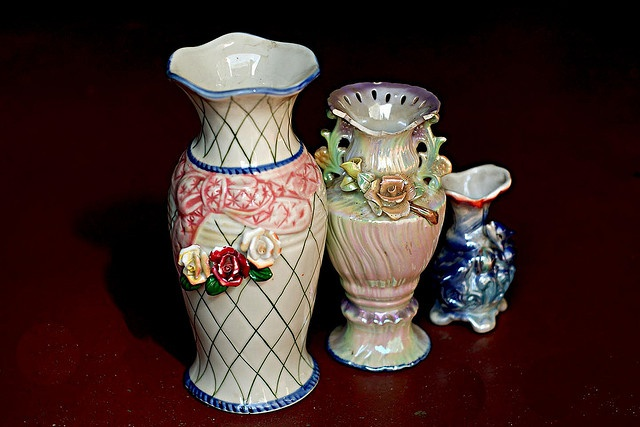Describe the objects in this image and their specific colors. I can see vase in black, darkgray, lightgray, and tan tones, vase in black, darkgray, tan, and gray tones, and vase in black, darkgray, gray, and navy tones in this image. 